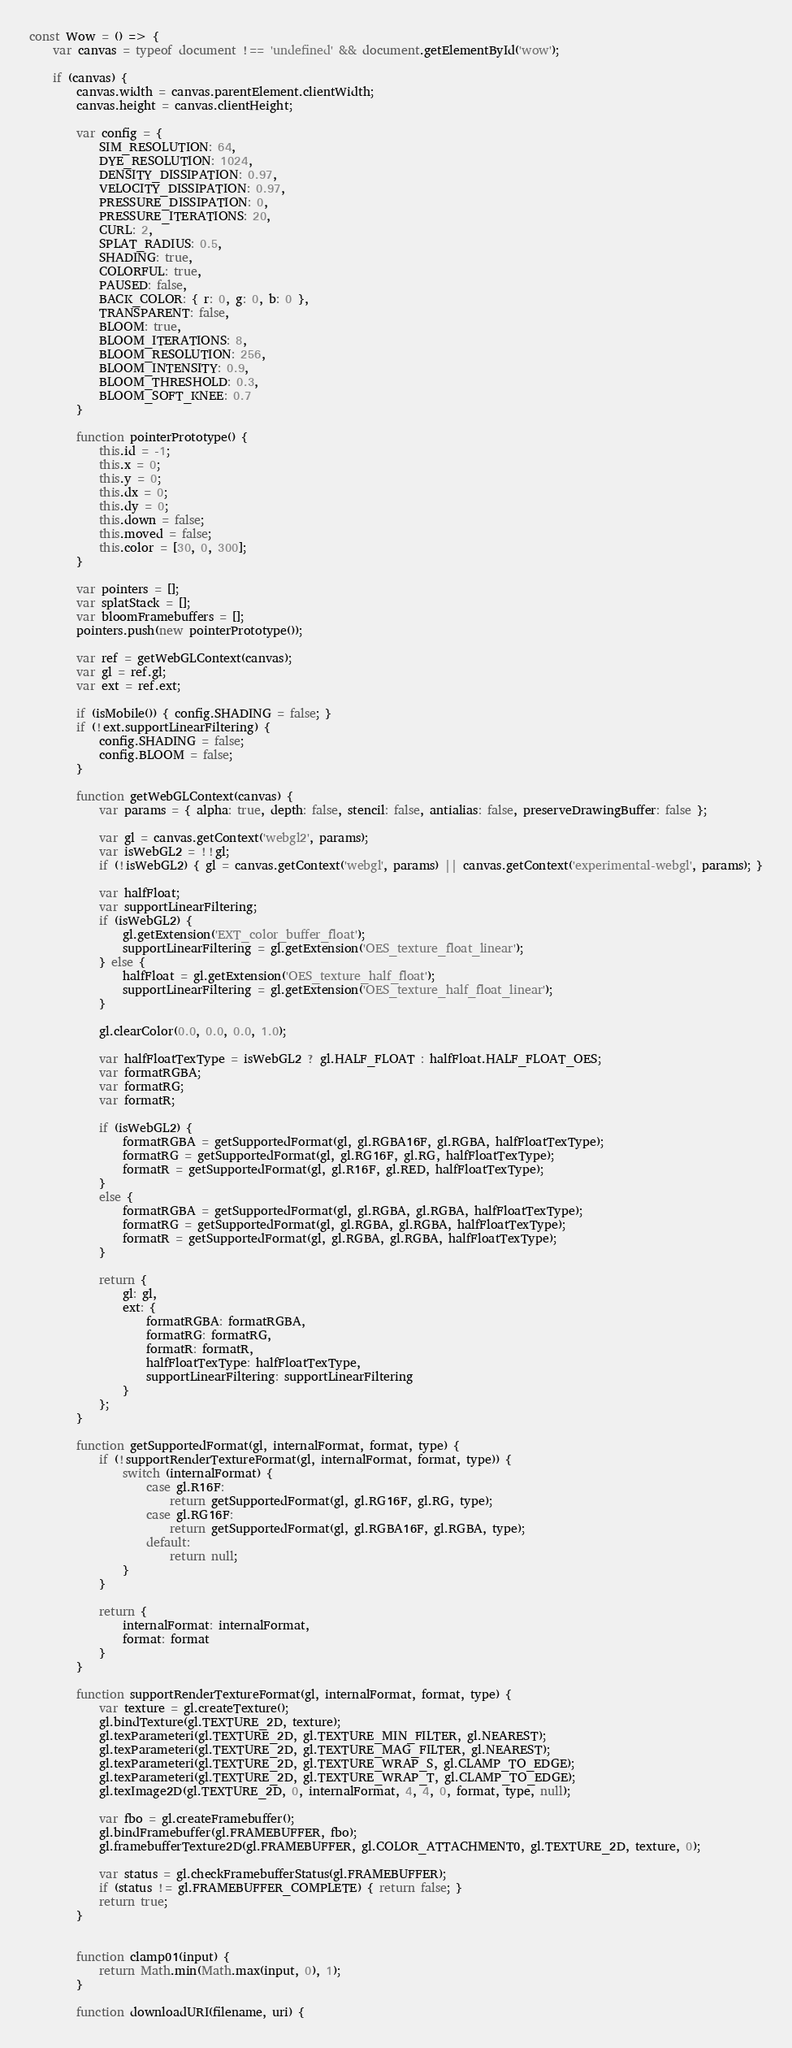<code> <loc_0><loc_0><loc_500><loc_500><_JavaScript_>const Wow = () => {
    var canvas = typeof document !== 'undefined' && document.getElementById('wow');
    
    if (canvas) {
        canvas.width = canvas.parentElement.clientWidth;
        canvas.height = canvas.clientHeight;
 
        var config = {
            SIM_RESOLUTION: 64,
            DYE_RESOLUTION: 1024,
            DENSITY_DISSIPATION: 0.97,
            VELOCITY_DISSIPATION: 0.97,
            PRESSURE_DISSIPATION: 0,
            PRESSURE_ITERATIONS: 20,
            CURL: 2,
            SPLAT_RADIUS: 0.5,
            SHADING: true,
            COLORFUL: true,
            PAUSED: false,
            BACK_COLOR: { r: 0, g: 0, b: 0 },
            TRANSPARENT: false,
            BLOOM: true,
            BLOOM_ITERATIONS: 8,
            BLOOM_RESOLUTION: 256,
            BLOOM_INTENSITY: 0.9,
            BLOOM_THRESHOLD: 0.3,
            BLOOM_SOFT_KNEE: 0.7
        }

        function pointerPrototype() {
            this.id = -1;
            this.x = 0;
            this.y = 0;
            this.dx = 0;
            this.dy = 0;
            this.down = false;
            this.moved = false;
            this.color = [30, 0, 300];
        }

        var pointers = [];
        var splatStack = [];
        var bloomFramebuffers = [];
        pointers.push(new pointerPrototype());

        var ref = getWebGLContext(canvas);
        var gl = ref.gl;
        var ext = ref.ext;

        if (isMobile()) { config.SHADING = false; }
        if (!ext.supportLinearFiltering) {
            config.SHADING = false;
            config.BLOOM = false;
        }

        function getWebGLContext(canvas) {
            var params = { alpha: true, depth: false, stencil: false, antialias: false, preserveDrawingBuffer: false };

            var gl = canvas.getContext('webgl2', params);
            var isWebGL2 = !!gl;
            if (!isWebGL2) { gl = canvas.getContext('webgl', params) || canvas.getContext('experimental-webgl', params); }

            var halfFloat;
            var supportLinearFiltering;
            if (isWebGL2) {
                gl.getExtension('EXT_color_buffer_float');
                supportLinearFiltering = gl.getExtension('OES_texture_float_linear');
            } else {
                halfFloat = gl.getExtension('OES_texture_half_float');
                supportLinearFiltering = gl.getExtension('OES_texture_half_float_linear');
            }

            gl.clearColor(0.0, 0.0, 0.0, 1.0);

            var halfFloatTexType = isWebGL2 ? gl.HALF_FLOAT : halfFloat.HALF_FLOAT_OES;
            var formatRGBA;
            var formatRG;
            var formatR;

            if (isWebGL2) {
                formatRGBA = getSupportedFormat(gl, gl.RGBA16F, gl.RGBA, halfFloatTexType);
                formatRG = getSupportedFormat(gl, gl.RG16F, gl.RG, halfFloatTexType);
                formatR = getSupportedFormat(gl, gl.R16F, gl.RED, halfFloatTexType);
            }
            else {
                formatRGBA = getSupportedFormat(gl, gl.RGBA, gl.RGBA, halfFloatTexType);
                formatRG = getSupportedFormat(gl, gl.RGBA, gl.RGBA, halfFloatTexType);
                formatR = getSupportedFormat(gl, gl.RGBA, gl.RGBA, halfFloatTexType);
            }

            return {
                gl: gl,
                ext: {
                    formatRGBA: formatRGBA,
                    formatRG: formatRG,
                    formatR: formatR,
                    halfFloatTexType: halfFloatTexType,
                    supportLinearFiltering: supportLinearFiltering
                }
            };
        }

        function getSupportedFormat(gl, internalFormat, format, type) {
            if (!supportRenderTextureFormat(gl, internalFormat, format, type)) {
                switch (internalFormat) {
                    case gl.R16F:
                        return getSupportedFormat(gl, gl.RG16F, gl.RG, type);
                    case gl.RG16F:
                        return getSupportedFormat(gl, gl.RGBA16F, gl.RGBA, type);
                    default:
                        return null;
                }
            }

            return {
                internalFormat: internalFormat,
                format: format
            }
        }

        function supportRenderTextureFormat(gl, internalFormat, format, type) {
            var texture = gl.createTexture();
            gl.bindTexture(gl.TEXTURE_2D, texture);
            gl.texParameteri(gl.TEXTURE_2D, gl.TEXTURE_MIN_FILTER, gl.NEAREST);
            gl.texParameteri(gl.TEXTURE_2D, gl.TEXTURE_MAG_FILTER, gl.NEAREST);
            gl.texParameteri(gl.TEXTURE_2D, gl.TEXTURE_WRAP_S, gl.CLAMP_TO_EDGE);
            gl.texParameteri(gl.TEXTURE_2D, gl.TEXTURE_WRAP_T, gl.CLAMP_TO_EDGE);
            gl.texImage2D(gl.TEXTURE_2D, 0, internalFormat, 4, 4, 0, format, type, null);

            var fbo = gl.createFramebuffer();
            gl.bindFramebuffer(gl.FRAMEBUFFER, fbo);
            gl.framebufferTexture2D(gl.FRAMEBUFFER, gl.COLOR_ATTACHMENT0, gl.TEXTURE_2D, texture, 0);

            var status = gl.checkFramebufferStatus(gl.FRAMEBUFFER);
            if (status != gl.FRAMEBUFFER_COMPLETE) { return false; }
            return true;
        }


        function clamp01(input) {
            return Math.min(Math.max(input, 0), 1);
        }

        function downloadURI(filename, uri) {</code> 